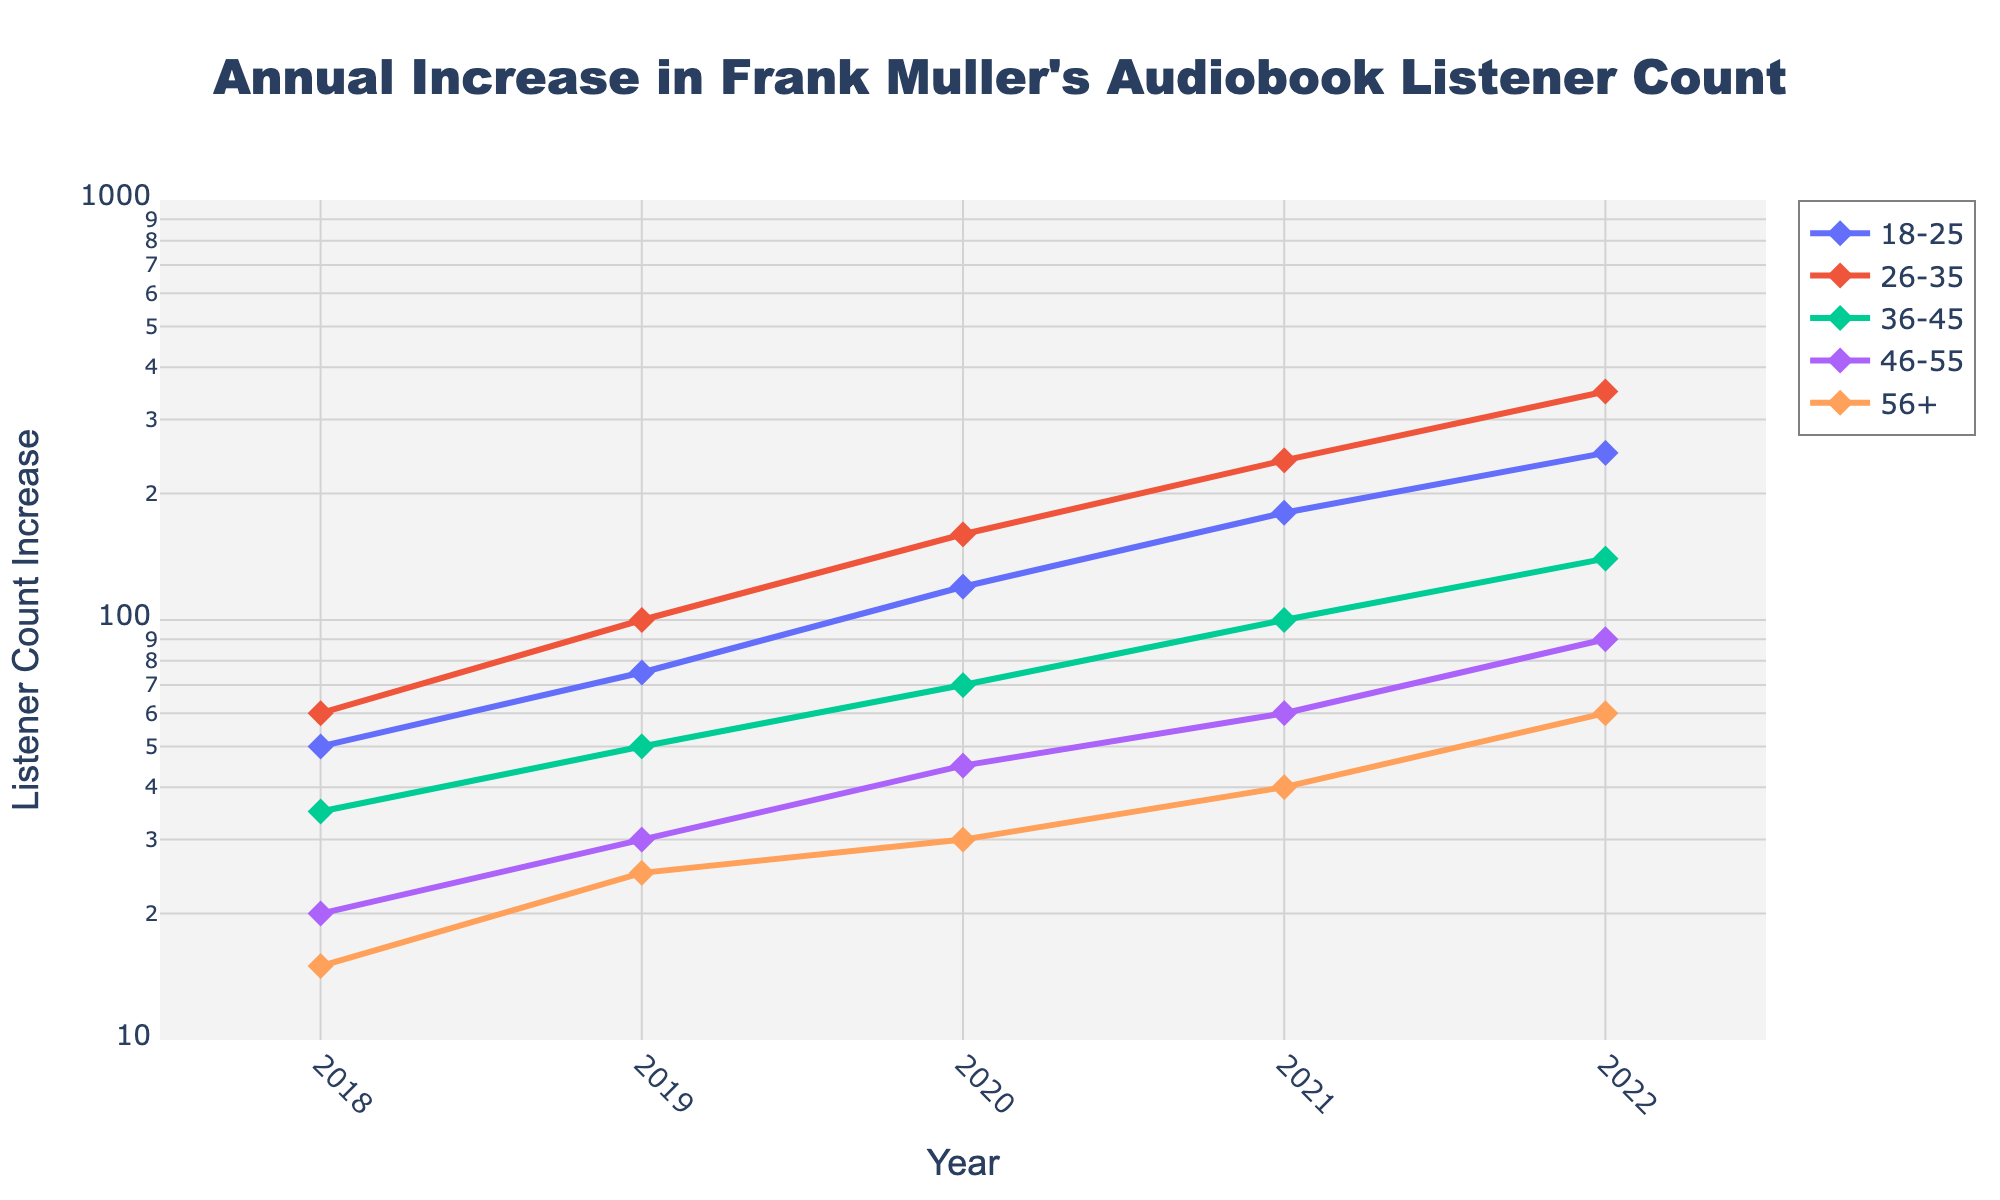What is the title of the figure? The title is usually found at the top of the figure and is enclosed in a larger font size compared to other text elements.
Answer: Annual Increase in Frank Muller's Audiobook Listener Count What is the axis title for the x-axis? The x-axis title describes what the horizontal axis represents, usually located below the axis.
Answer: Year How many age groups are presented in the figure? Each age group is typically represented by a distinct line with markers in the plot legend. Count the unique age groups in the legend.
Answer: 5 In which year did the 18-25 age group see the most significant increase in listeners? Examine the markers or points for the 18-25 age group line on the plot and identify the year with the highest y-value.
Answer: 2022 Which age group had the highest increase in listeners in 2022? Compare the y-values of different age groups for the year 2022 and identify the group with the highest value.
Answer: 26-35 Between which consecutive years did the 26-35 age group experience the largest increase? Examine the increments in the y-values for the 26-35 age group between each pair of consecutive years and identify the largest increment.
Answer: 2021-2022 How does the listener count increase for the 46-55 age group in 2022 compare to the 18-25 age group in 2020? Compare the y-values of the 46-55 age group in 2022 to the 18-25 age group in 2020. The log scale requires reading values distinctly.
Answer: 46-55 in 2022 had a higher increase What pattern do you observe in the listener increase for the 56+ age group over the years? Observe and describe the trend of the y-values for the 56+ age group across the years.
Answer: Gradual increase Which age group had the least increase in listeners in 2019? Compare the y-values of each age group for 2019 and identify the lowest value.
Answer: 46-55 What is the range of the x-axis in the figure? The x-axis range can be determined by looking at the starting and ending values presented on the axis.
Answer: 2017.5 to 2022.5 